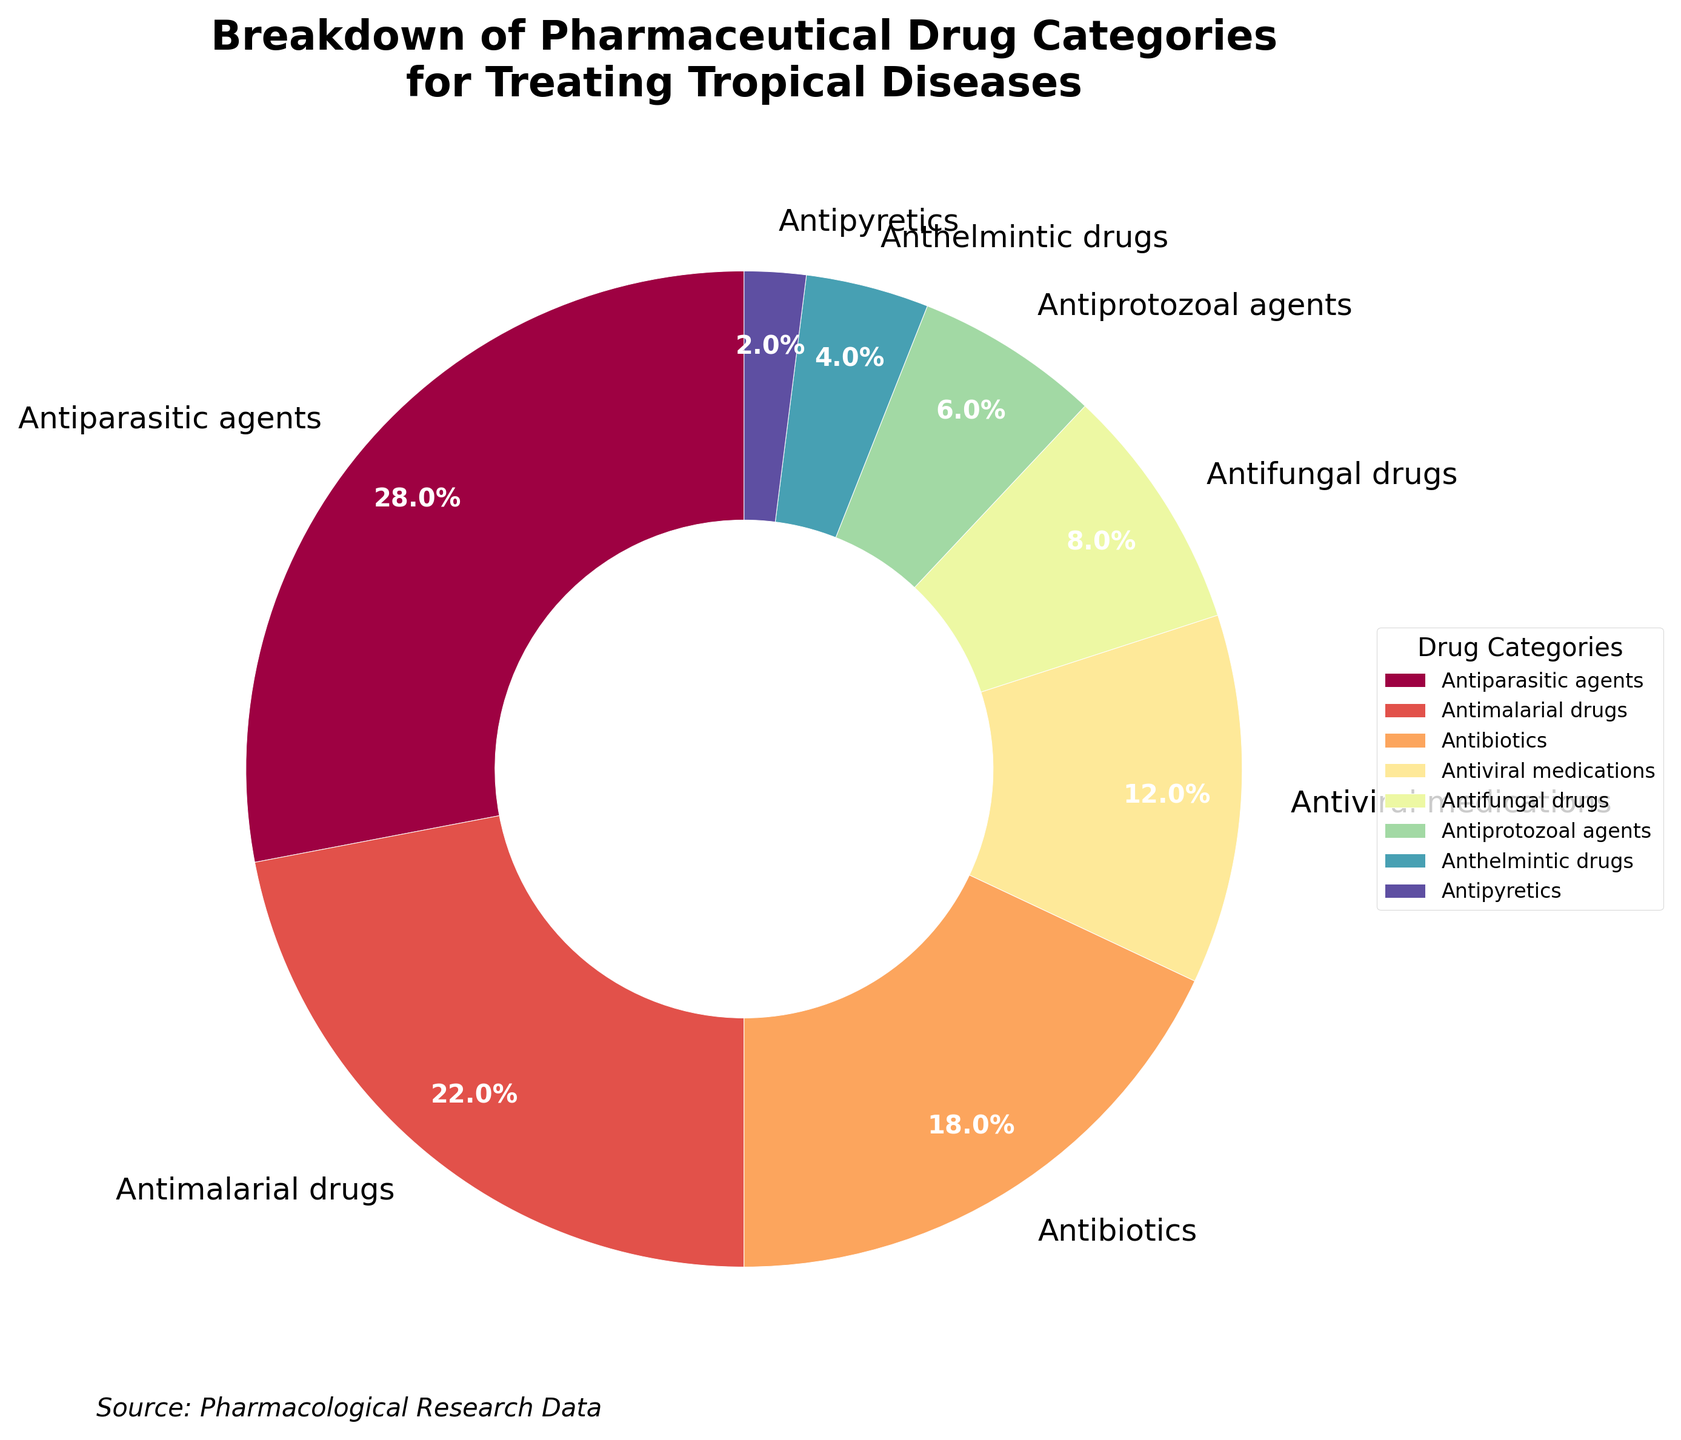What percentage of drugs used for treating tropical diseases are Antimalarial drugs? Antimalarial drugs represent 22% of the total pharmaceutical drug categories treating tropical diseases, as shown in the pie chart.
Answer: 22% Which drug category has the smallest share, and what is its percentage? The drug category with the smallest share is Antipyretics, contributing 2% of the total pharmaceutical drug categories.
Answer: Antipyretics, 2% How much more significant is the proportion of Antiparasitic agents compared to Antipyretics? Antiparasitic agents make up 28%, and Antipyretics account for 2%. The difference in their proportions is 28% - 2% = 26%.
Answer: 26% Which two drug categories combined form exactly half (50%) of the total? Antiparasitic agents (28%) and Antimalarial drugs (22%) together account for 28% + 22% = 50% of the total.
Answer: Antiparasitic agents and Antimalarial drugs Among Antiviral medications, Antifungal drugs, Antiprotozoal agents, and Anthelmintic drugs, which has the highest percentage, and what is it? Antiviral medications have the highest percentage among these categories with a proportion of 12%.
Answer: Antiviral medications, 12% What is the combined percentage of Antibiotics, Antifungal drugs, and Antipyretics? The combined percentage is calculated as follows: Antibiotics (18%) + Antifungal drugs (8%) + Antipyretics (2%) = 18% + 8% + 2% = 28%.
Answer: 28% Compare the percentage of Antiviral medications to Antifungal drugs. Which one is greater, and by how much? Antiviral medications are 12%, and Antifungal drugs are 8%. The difference is 12% - 8% = 4%.
Answer: Antiviral medications, 4% What is the difference in percentage between Antimalarial drugs and Anthelmintic drugs? The percentage difference is calculated by subtracting Anthelmintic drugs' percentage (4%) from that of Antimalarial drugs (22%). So, 22% - 4% = 18%.
Answer: 18% If we group Antiparasitic agents, Antimalarial drugs, and Antiprotozoal agents together, what percentage do they represent? Adding their percentages: Antiparasitic agents (28%) + Antimalarial drugs (22%) + Antiprotozoal agents (6%) results in 28% + 22% + 6% = 56%.
Answer: 56% Which drug category's wedge in the pie chart is the brightest, and what percentage does it represent? Antiparasitic agents' wedge is the brightest, representing 28% of the total.
Answer: Antiparasitic agents, 28% 